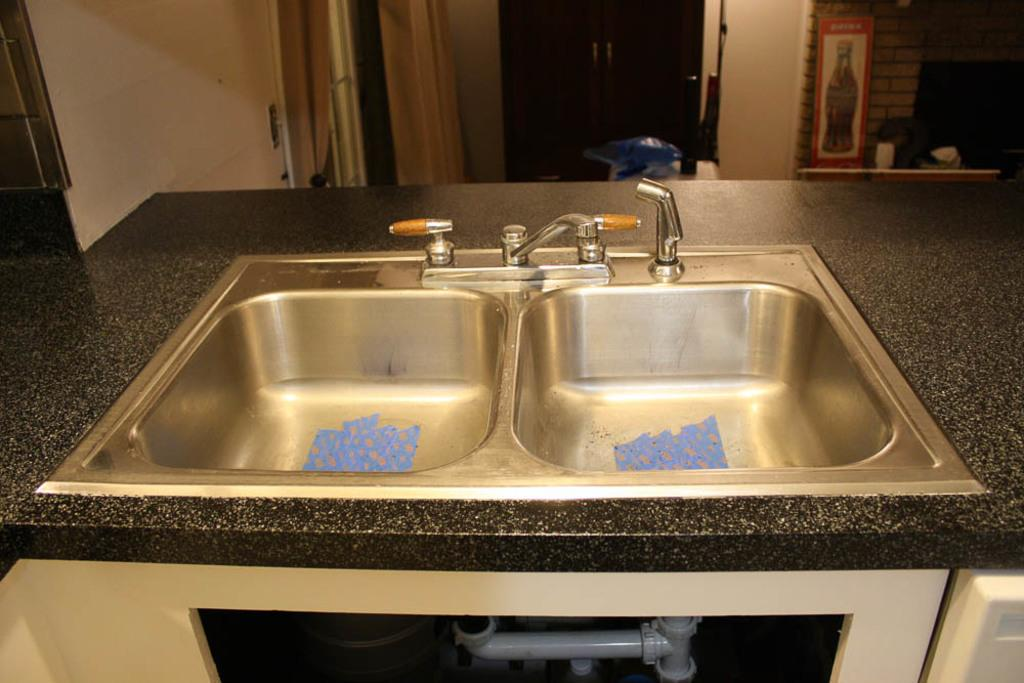How many sinks are visible in the image? There are two sinks in the image. What else can be seen in the image besides the sinks? There are tapes and a door visible in the image. What type of window treatment is present on the left side of the image? There is a curtain on the left side of the image. What is the color of the pipe under the sinks in the image? The pipe under the sinks is white in color. Where is the mailbox located in the image? There is no mailbox present in the image. How many passengers are visible in the image? There are no passengers present in the image. 